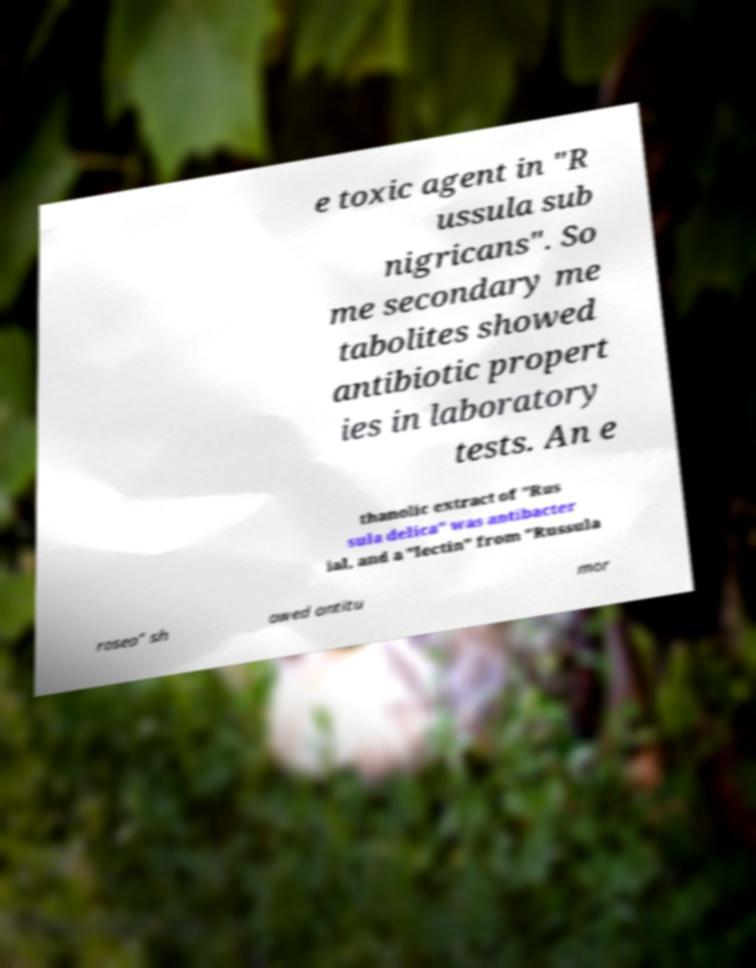Please read and relay the text visible in this image. What does it say? e toxic agent in "R ussula sub nigricans". So me secondary me tabolites showed antibiotic propert ies in laboratory tests. An e thanolic extract of "Rus sula delica" was antibacter ial, and a "lectin" from "Russula rosea" sh owed antitu mor 